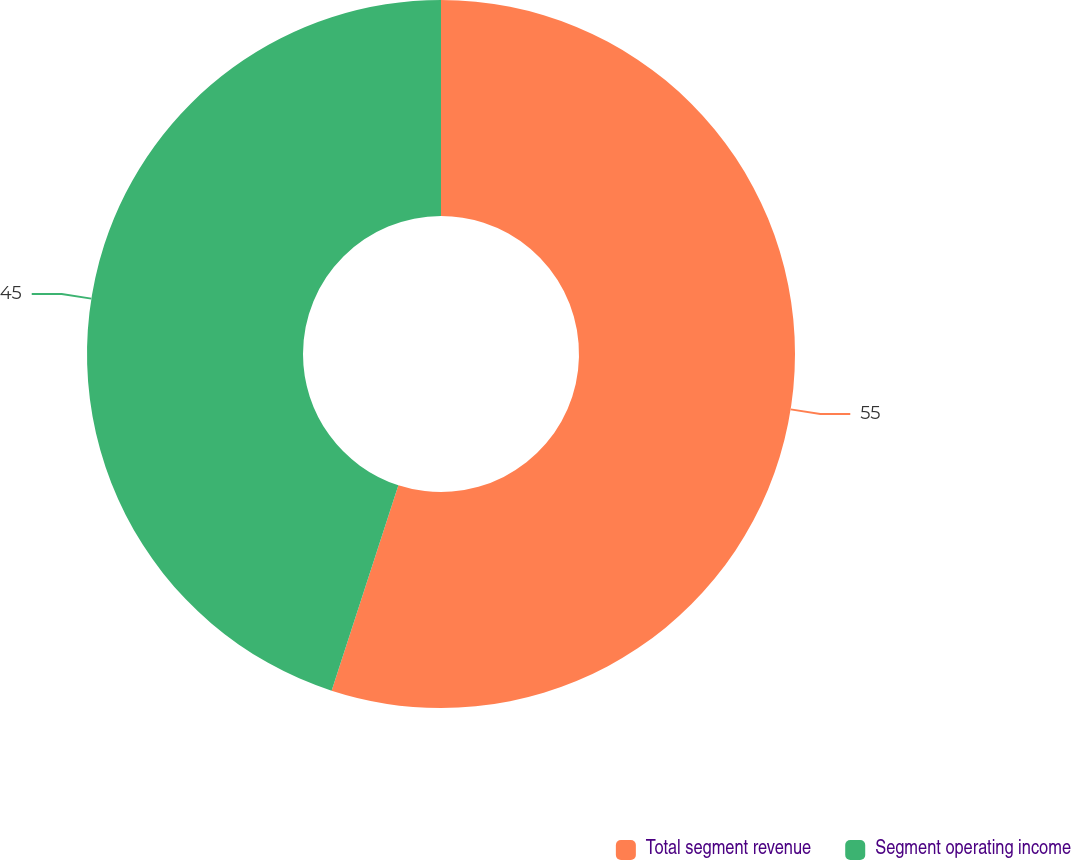Convert chart to OTSL. <chart><loc_0><loc_0><loc_500><loc_500><pie_chart><fcel>Total segment revenue<fcel>Segment operating income<nl><fcel>55.0%<fcel>45.0%<nl></chart> 